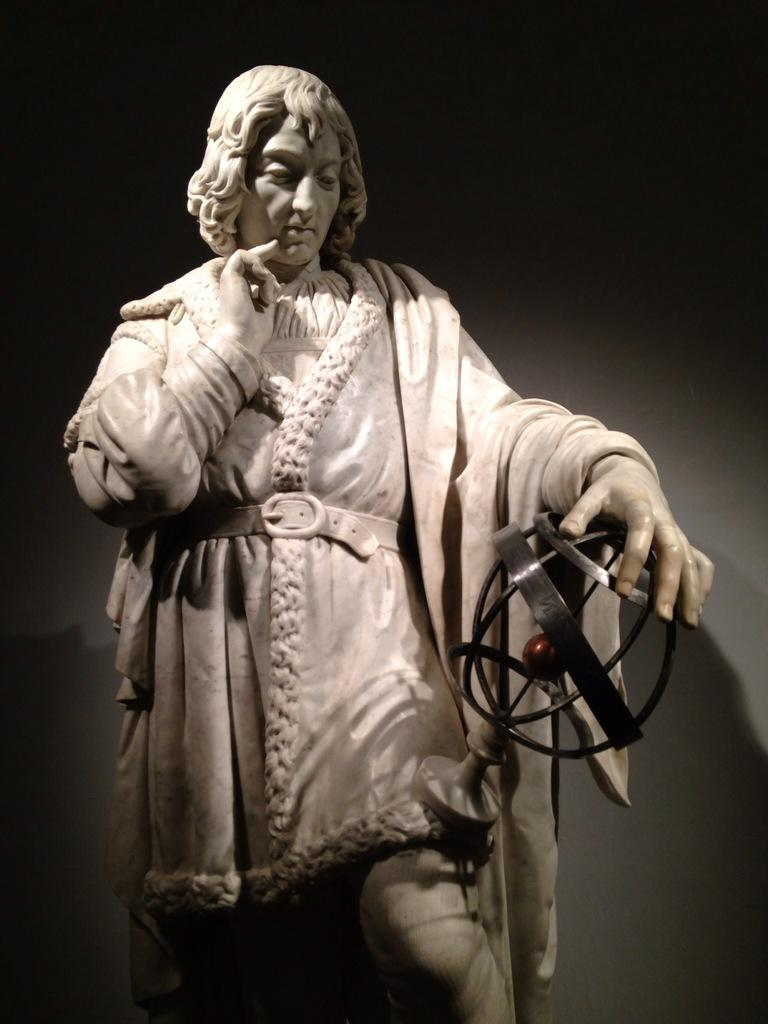What is the main subject of the image? There is a sculpture in the image. How is the sculpture positioned? The sculpture is standing. What is the sculpture holding in its hand? The sculpture is holding a round-shaped object. What can be observed about the background of the image? The background of the image is dark. What type of farmer is shown in the image? There is no farmer present in the image; it features a sculpture holding a round-shaped object. What emotion does the sculpture express towards the round-shaped object? The sculpture's emotions cannot be determined from the image, as it is a static object. 